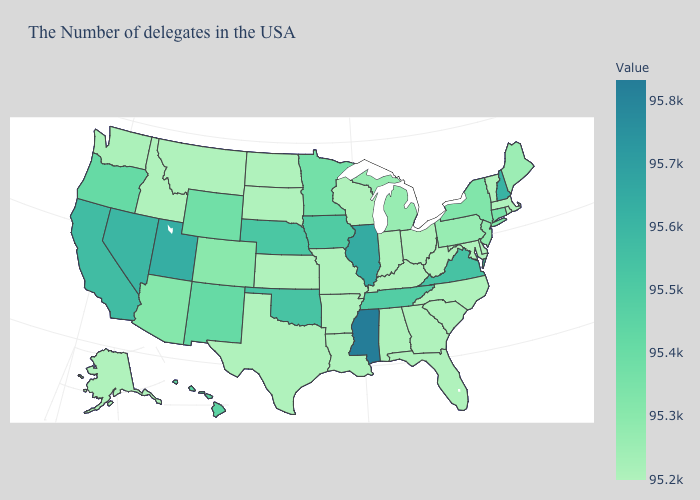Among the states that border Montana , which have the highest value?
Be succinct. Wyoming. Among the states that border Mississippi , which have the highest value?
Answer briefly. Tennessee. Is the legend a continuous bar?
Be succinct. Yes. Which states have the lowest value in the South?
Write a very short answer. Maryland, North Carolina, South Carolina, West Virginia, Florida, Georgia, Kentucky, Alabama, Louisiana, Arkansas, Texas. Which states have the lowest value in the Northeast?
Write a very short answer. Massachusetts, Rhode Island, Vermont. 